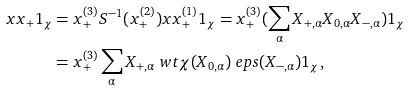Convert formula to latex. <formula><loc_0><loc_0><loc_500><loc_500>x x _ { + } 1 _ { \chi } & = x _ { + } ^ { ( 3 ) } S ^ { - 1 } ( x _ { + } ^ { ( 2 ) } ) x x _ { + } ^ { ( 1 ) } 1 _ { \chi } = x _ { + } ^ { ( 3 ) } ( \sum _ { \alpha } X _ { + , \alpha } X _ { 0 , \alpha } X _ { - , \alpha } ) 1 _ { \chi } \\ & = x _ { + } ^ { ( 3 ) } \sum _ { \alpha } X _ { + , \alpha } \ w t \chi ( X _ { 0 , \alpha } ) \ e p s ( X _ { - , \alpha } ) 1 _ { \chi } ,</formula> 